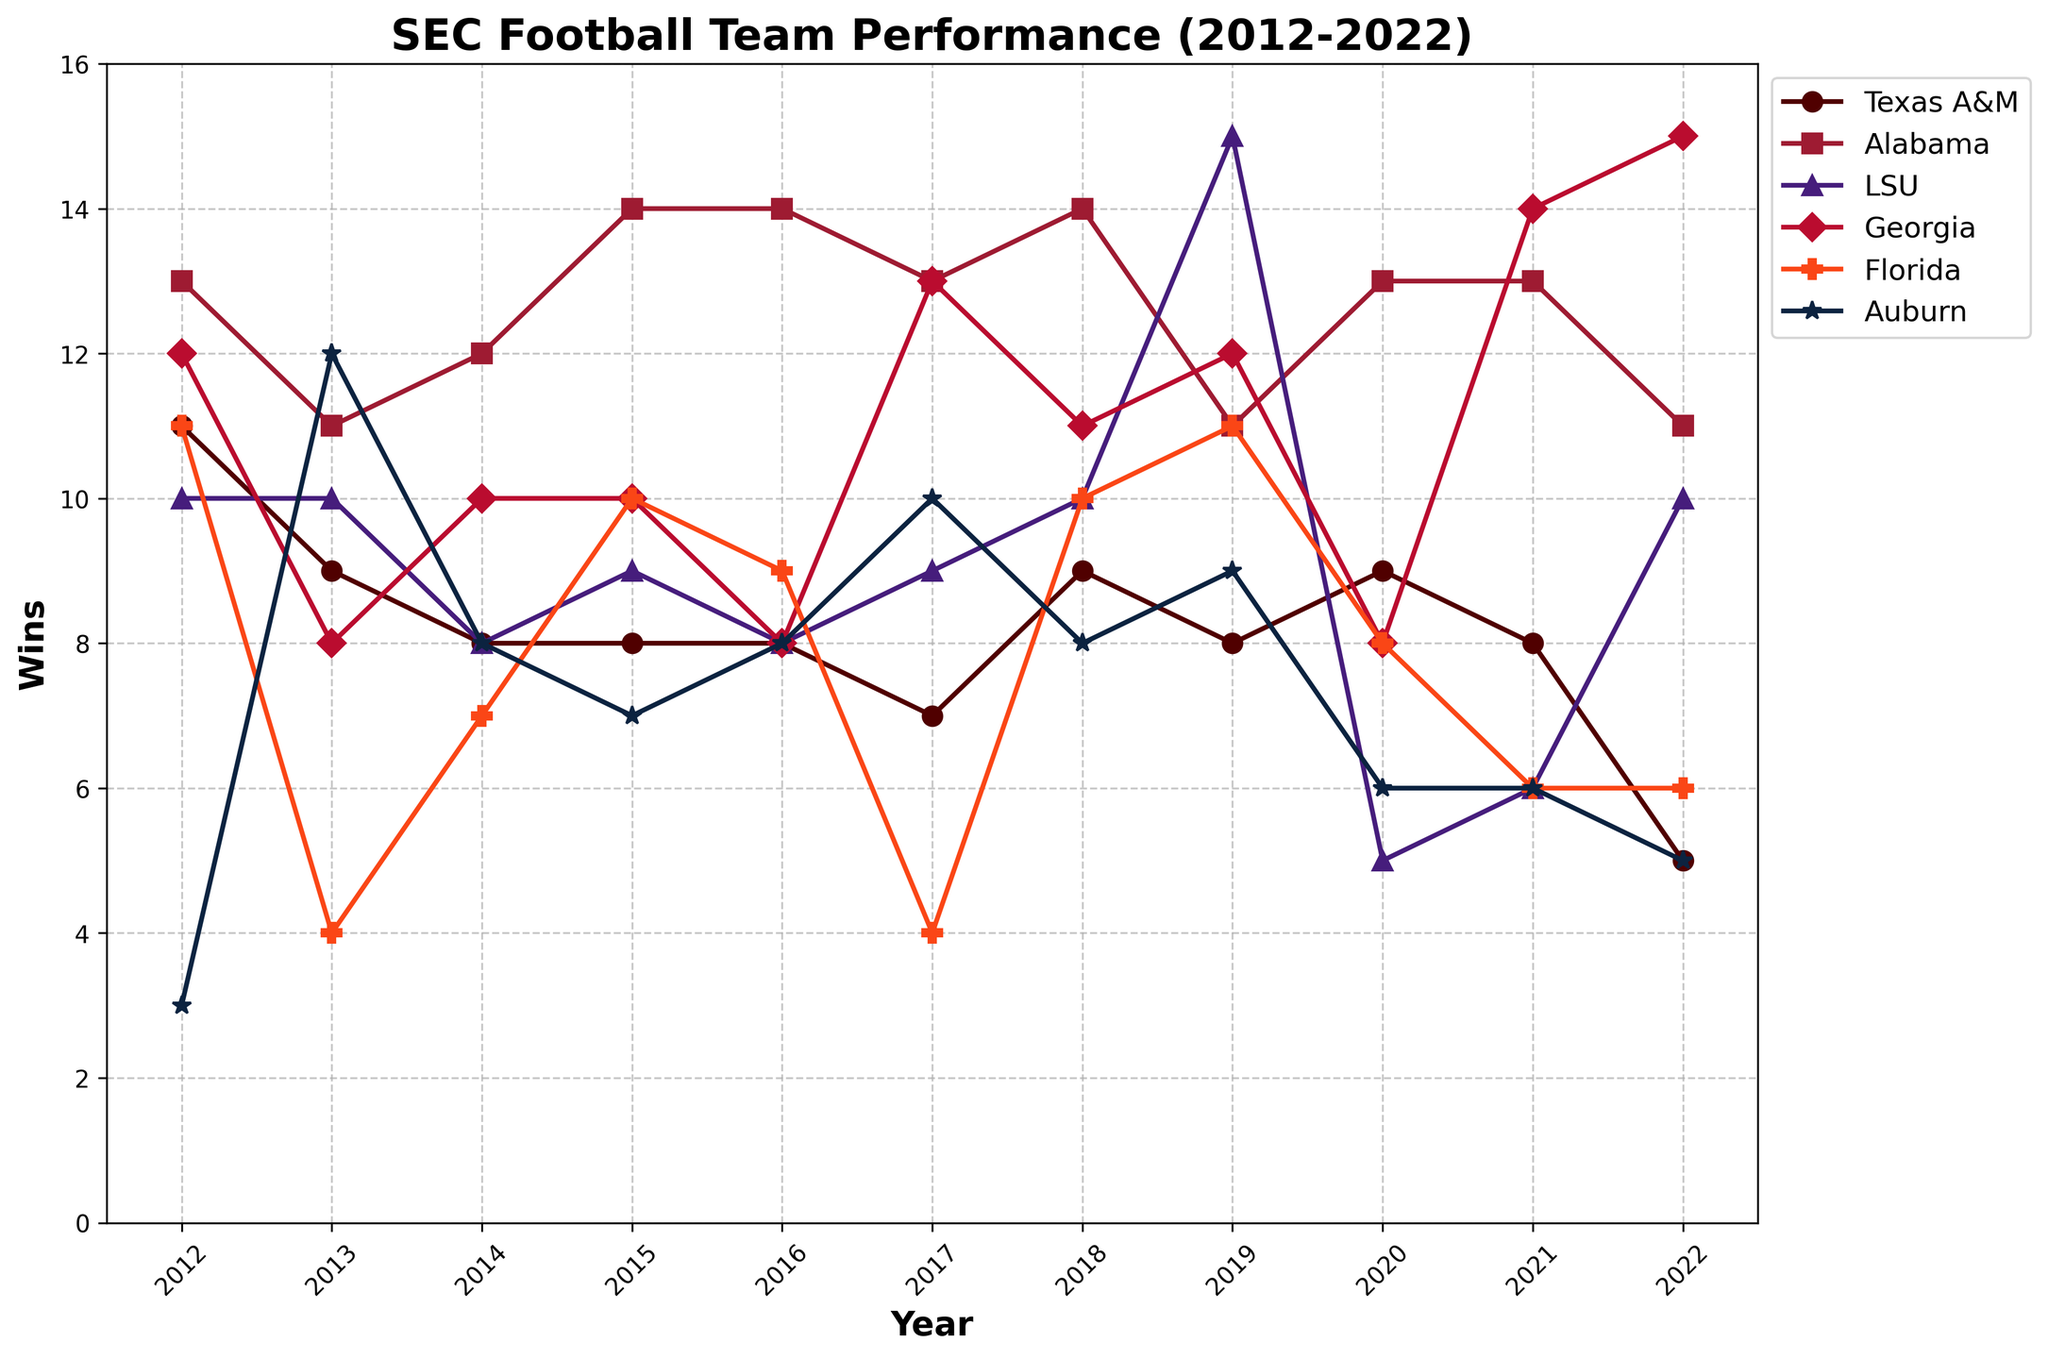Which team had the highest number of wins in 2022? Look at the data points for the year 2022 and identify the team with the highest value. Georgia has the highest point for that year.
Answer: Georgia What is the average number of wins for Texas A&M from 2012 to 2022? First, extract the win records for Texas A&M for each year (11, 9, 8, 8, 8, 7, 9, 8, 9, 8, 5). Add them up to get a total of 90. Then, divide by the number of years (11). 90/11 = 8.18.
Answer: 8.18 Which year did Auburn have the same number of wins as Florida? Scan the lines for both Auburn and Florida to find a year where their points overlap. In 2021, both teams have their points at 6.
Answer: 2021 Compare the performance of LSU and Alabama in 2019. Which team had more wins and by how many? In 2019, LSU had 15 wins and Alabama had 11 wins. The difference is 15 - 11 = 4.
Answer: LSU by 4 Identify the team with the most fluctuating win record between 2012 and 2022 and explain why. Notice the lines for each team and assess which one has the most changes up and down. Auburn's record varies significantly with wins such as 3 in 2012, up to 12 in 2013, down to 8 multiple times, and then hitting lows of 5 and 6.
Answer: Auburn How did the number of wins for Georgia change from 2013 to 2021? Look at the data points for Georgia in 2013 (8 wins) and 2021 (14 wins). The change is 14 - 8 = 6 wins more.
Answer: Increased by 6 Which team had the lowest number of wins in any given year, and what was that number? Identify the lowest data point in the entire chart. Auburn had the lowest in 2012 with 3 wins.
Answer: Auburn with 3 wins Find the average number of wins for Alabama over the period and compare it to the average number of wins for Texas A&M over the same period. First, calculate the average for Alabama: (13 + 11 + 12 + 14 + 14 + 13 + 14 + 11 + 13 + 13 + 11) = 139/11 = 12.64. For Texas A&M: (11 + 9 + 8 + 8 + 8 + 7 + 9 + 8 + 9 + 8 + 5) = 90/11 = 8.18.
Answer: Alabama: 12.64, Texas A&M: 8.18 What is the range of wins for Georgia from 2012 to 2022? Identify the maximum and minimum wins for Georgia in the given years. The highest number is 15 (2022), and the lowest is 8 (2013). The range is 15 - 8 = 7.
Answer: 7 In which year did Texas A&M have the biggest improvement in wins compared to the previous year? Compare the number of wins year over year and find the largest increase. From 2011 (not provided, but inferred as a prior season) to 2012, Texas A&M improved from 7 wins to 11 wins.
Answer: 2012 